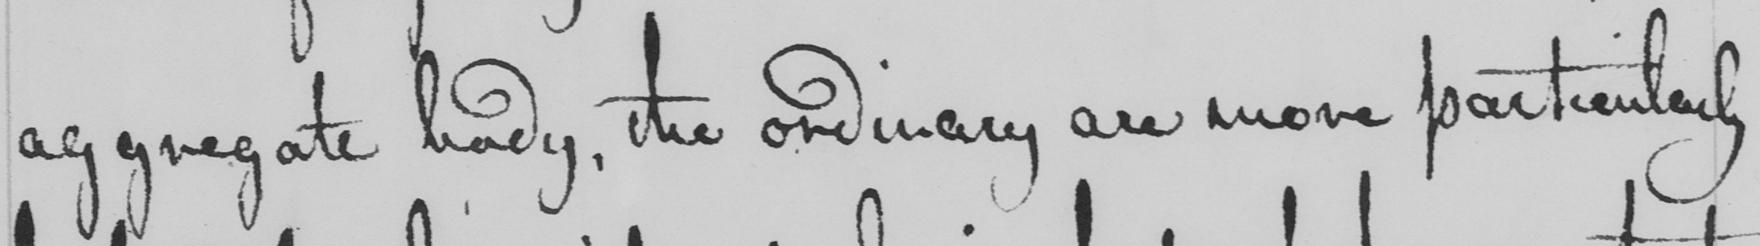Please provide the text content of this handwritten line. aggregate body , the ordinary are more particularly 